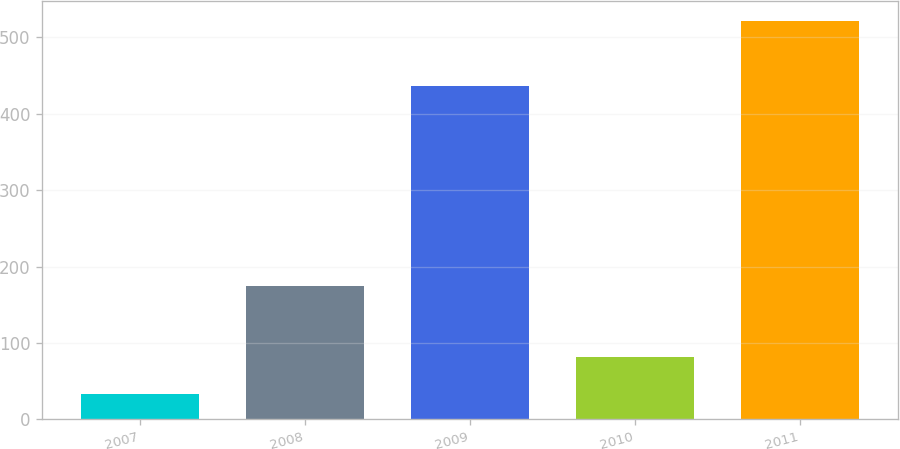Convert chart to OTSL. <chart><loc_0><loc_0><loc_500><loc_500><bar_chart><fcel>2007<fcel>2008<fcel>2009<fcel>2010<fcel>2011<nl><fcel>33<fcel>175<fcel>436<fcel>81.9<fcel>522<nl></chart> 